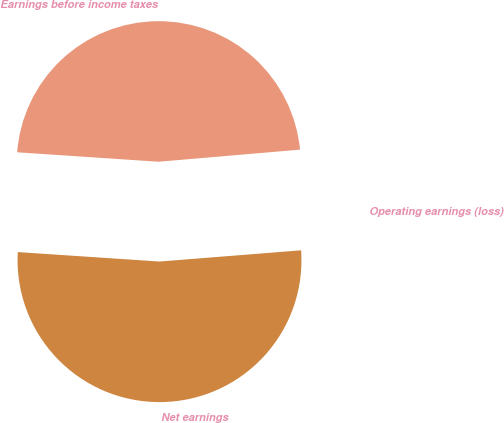Convert chart to OTSL. <chart><loc_0><loc_0><loc_500><loc_500><pie_chart><fcel>Operating earnings (loss)<fcel>Earnings before income taxes<fcel>Net earnings<nl><fcel>0.1%<fcel>47.58%<fcel>52.32%<nl></chart> 